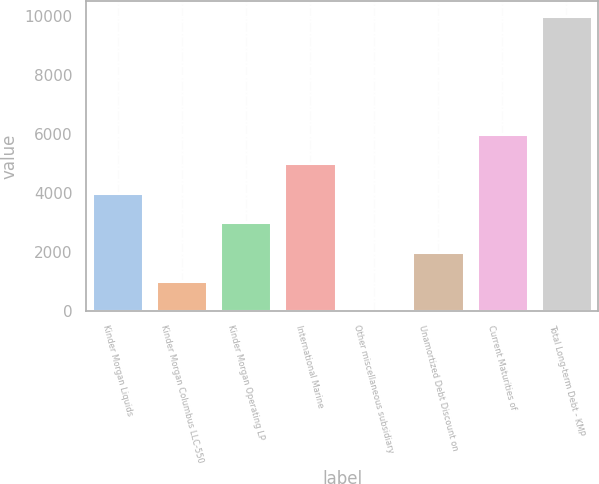Convert chart. <chart><loc_0><loc_0><loc_500><loc_500><bar_chart><fcel>Kinder Morgan Liquids<fcel>Kinder Morgan Columbus LLC-550<fcel>Kinder Morgan Operating LP<fcel>International Marine<fcel>Other miscellaneous subsidiary<fcel>Unamortized Debt Discount on<fcel>Current Maturities of<fcel>Total Long-term Debt - KMP<nl><fcel>4003.78<fcel>1001.92<fcel>3003.16<fcel>5004.4<fcel>1.3<fcel>2002.54<fcel>6005.02<fcel>10007.5<nl></chart> 